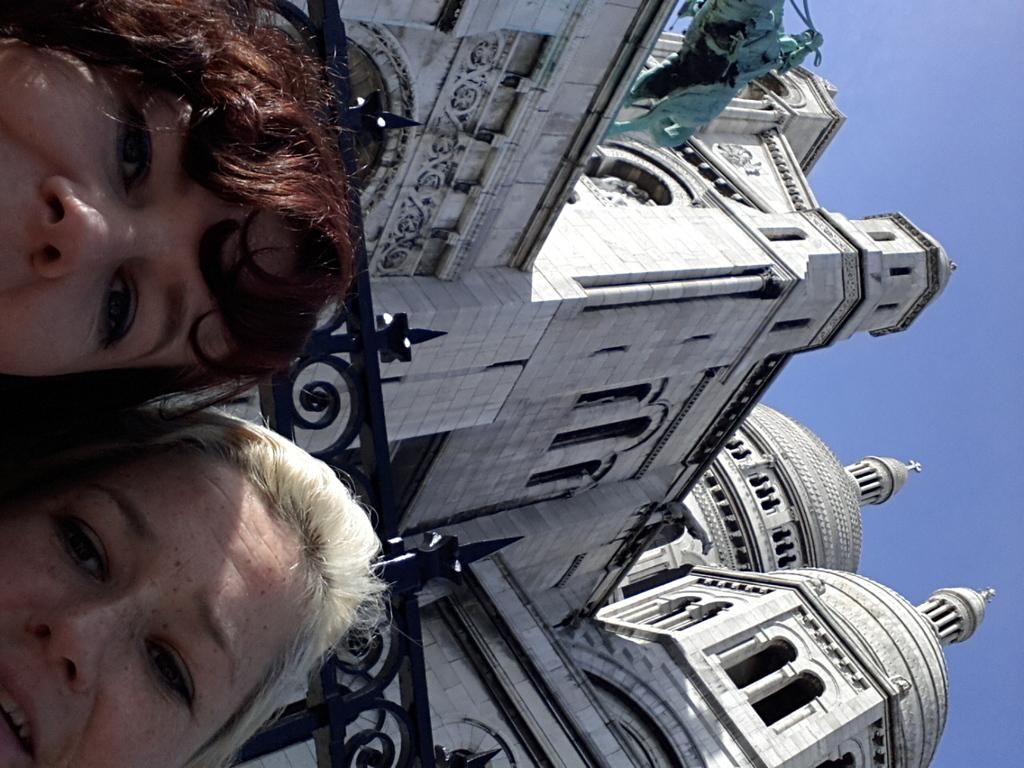How is the image oriented? The image is tilted. Who or what can be seen in the front of the image? There are two people in the front of the image. What is the large structure behind the people? There is a huge architecture behind the people. What can be found on the left side of the image? There is a sculpture on the left side of the image. What type of wax is being used to smash the elbow of the person on the right side of the image? There is no wax or elbow smashing present in the image; it only features two people, a huge architecture, and a sculpture. 